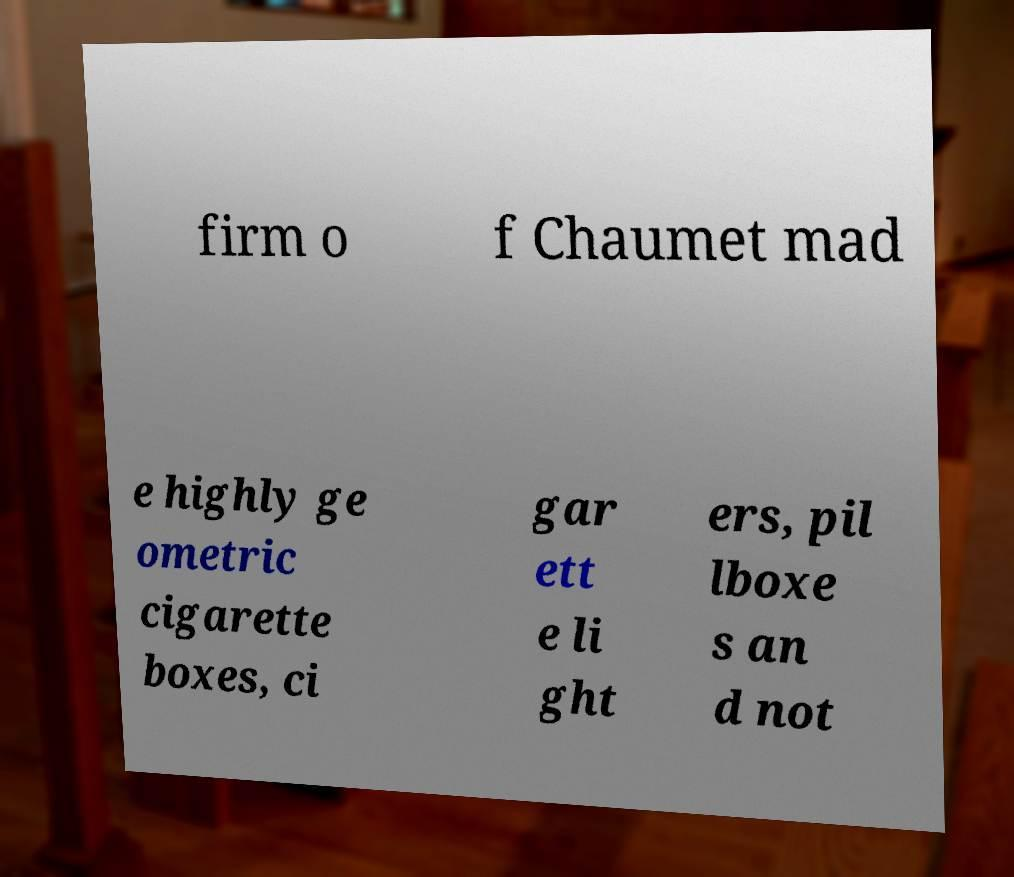Please read and relay the text visible in this image. What does it say? firm o f Chaumet mad e highly ge ometric cigarette boxes, ci gar ett e li ght ers, pil lboxe s an d not 